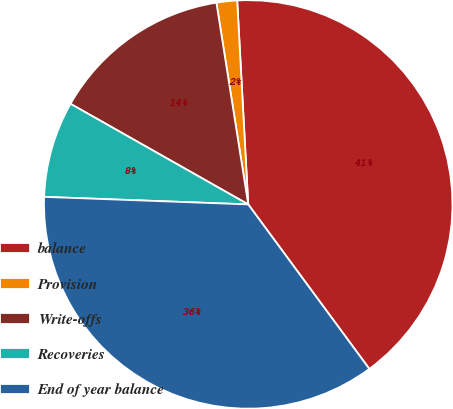<chart> <loc_0><loc_0><loc_500><loc_500><pie_chart><fcel>balance<fcel>Provision<fcel>Write-offs<fcel>Recoveries<fcel>End of year balance<nl><fcel>40.76%<fcel>1.63%<fcel>14.31%<fcel>7.61%<fcel>35.69%<nl></chart> 